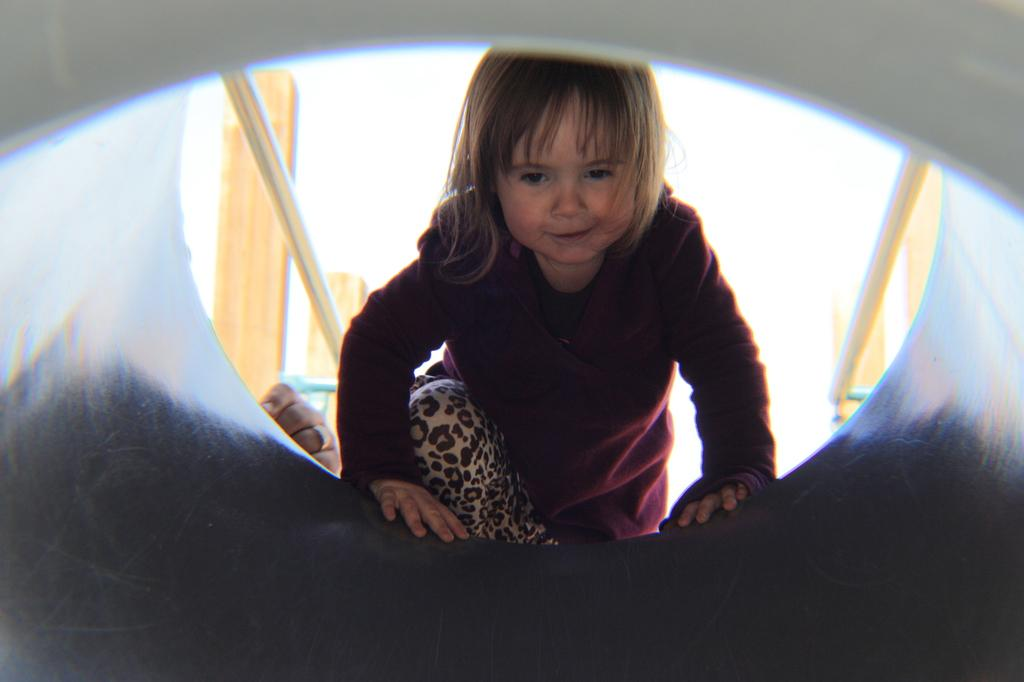What is the main subject of the image? The main subject of the image is a kid. What is the kid doing in the image? The kid is entering a tunnel-like structure. Can you describe any details about the background of the image? In the background, there is a ring on a person's finger and poles visible. There are also other unspecified objects present. What type of meat can be seen being sold at the market in the image? There is no market or meat present in the image; it features a kid entering a tunnel-like structure with a background that includes a ring on a person's finger and poles. How many trucks are visible in the image? There are no trucks visible in the image. 